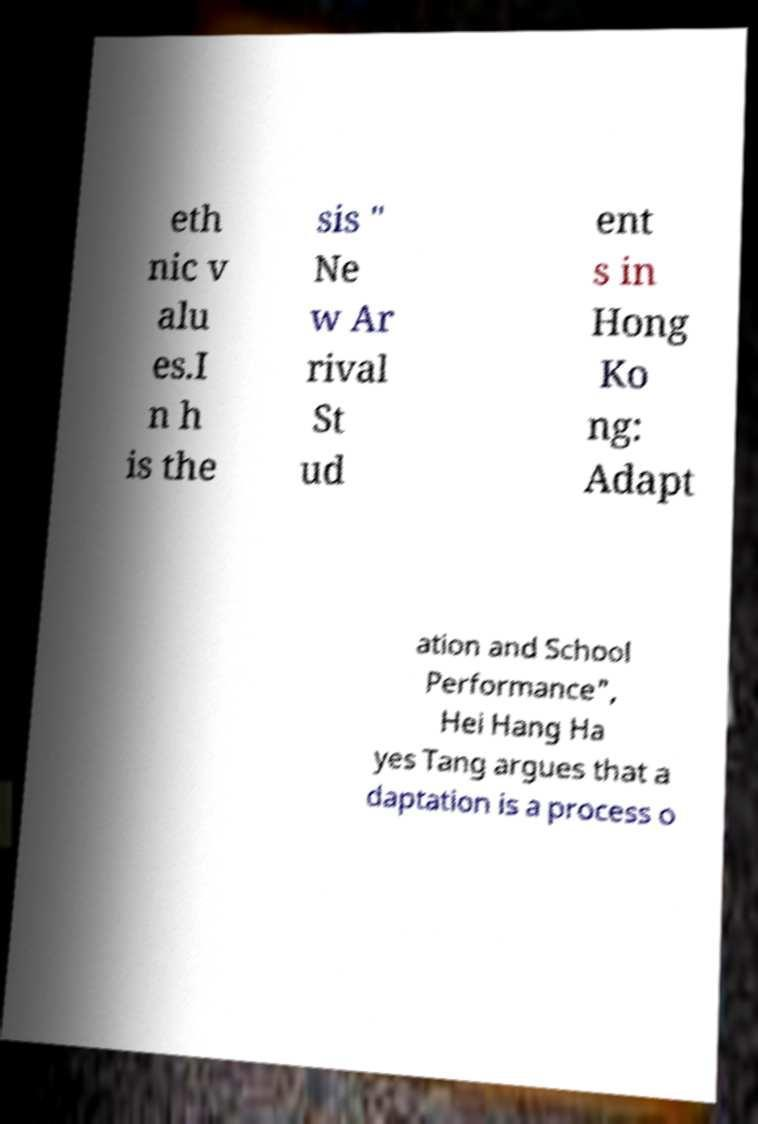Can you read and provide the text displayed in the image?This photo seems to have some interesting text. Can you extract and type it out for me? eth nic v alu es.I n h is the sis " Ne w Ar rival St ud ent s in Hong Ko ng: Adapt ation and School Performance", Hei Hang Ha yes Tang argues that a daptation is a process o 